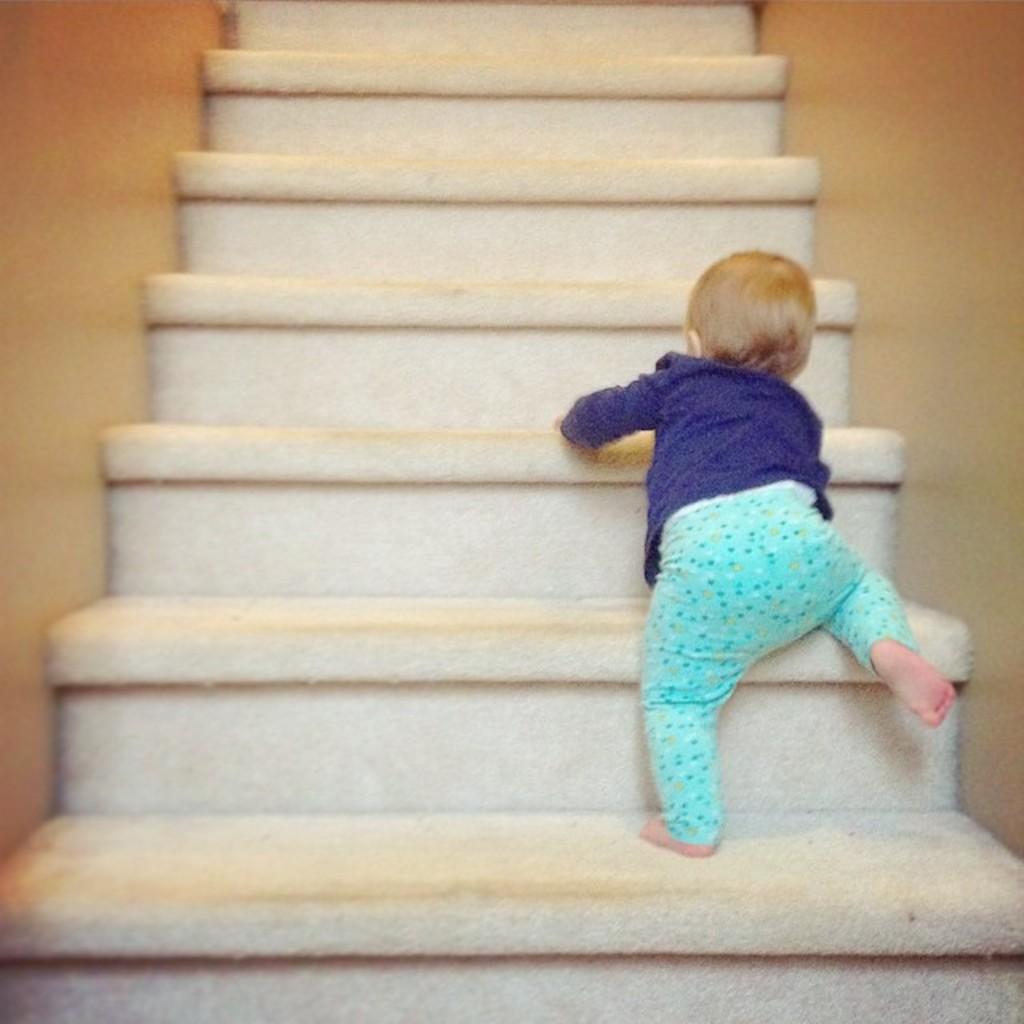How would you summarize this image in a sentence or two? There are steps. Through the steps a child is climbing. On the sides of the steps there are walls. 